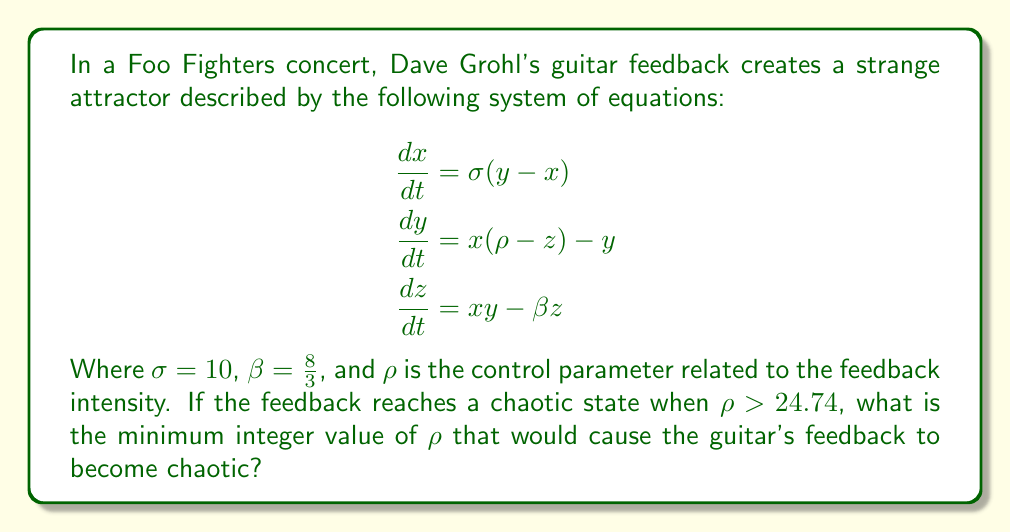Provide a solution to this math problem. To solve this problem, we need to understand the Lorenz system and its behavior in the context of guitar feedback:

1. The given system of equations is the Lorenz system, which is known to exhibit chaotic behavior under certain conditions.

2. The parameter $\rho$ (rho) is the control parameter that determines the system's behavior. In this case, it represents the intensity of the guitar feedback.

3. We're told that the system becomes chaotic when $\rho > 24.74$.

4. Since we're asked for the minimum integer value of $\rho$, we need to find the smallest whole number greater than 24.74.

5. The smallest integer greater than 24.74 is 25.

Therefore, the minimum integer value of $\rho$ that would cause the guitar's feedback to become chaotic is 25.

This means that when Dave Grohl's guitar feedback intensity reaches or exceeds this value, the sound will enter a chaotic state, producing complex and unpredictable patterns typical of the intense, distorted sounds often heard in late 90s rock music.
Answer: 25 